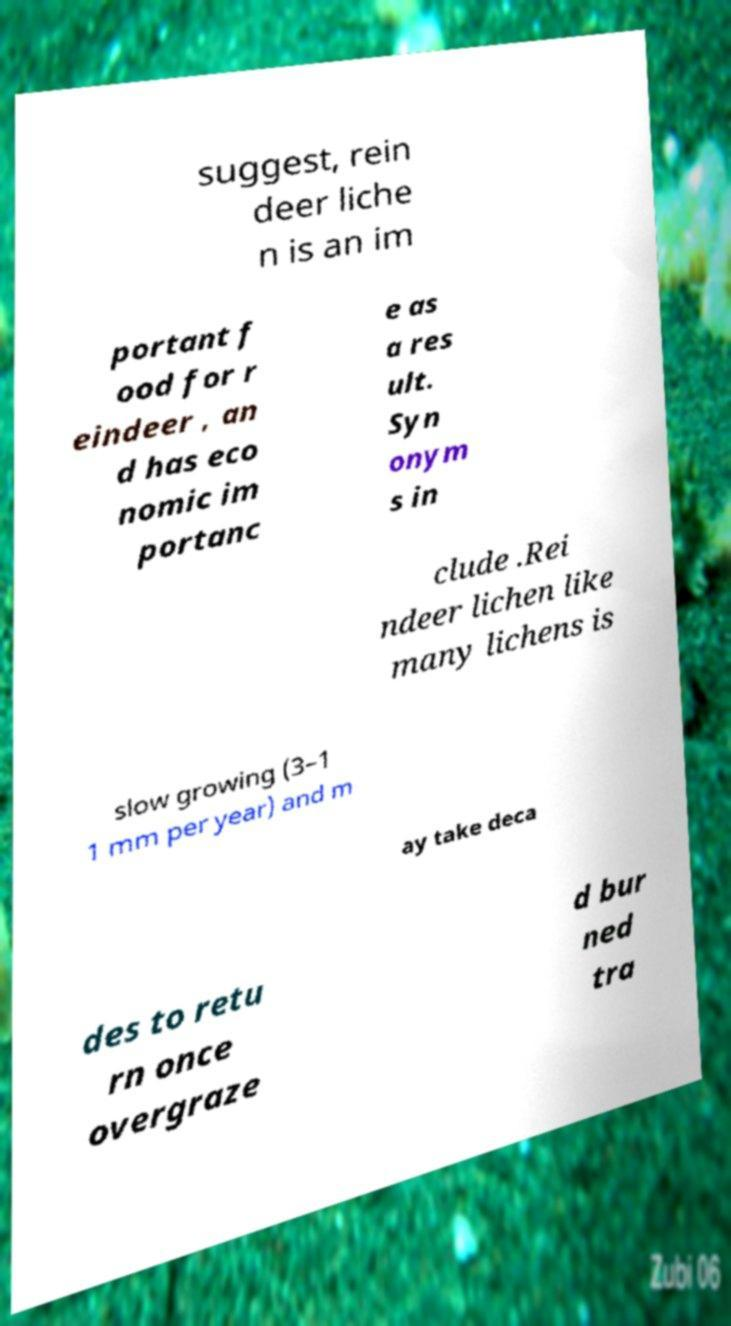Can you read and provide the text displayed in the image?This photo seems to have some interesting text. Can you extract and type it out for me? suggest, rein deer liche n is an im portant f ood for r eindeer , an d has eco nomic im portanc e as a res ult. Syn onym s in clude .Rei ndeer lichen like many lichens is slow growing (3–1 1 mm per year) and m ay take deca des to retu rn once overgraze d bur ned tra 